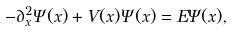Convert formula to latex. <formula><loc_0><loc_0><loc_500><loc_500>- \partial _ { x } ^ { 2 } \Psi ( x ) + V ( x ) \Psi ( x ) = E \Psi ( x ) ,</formula> 